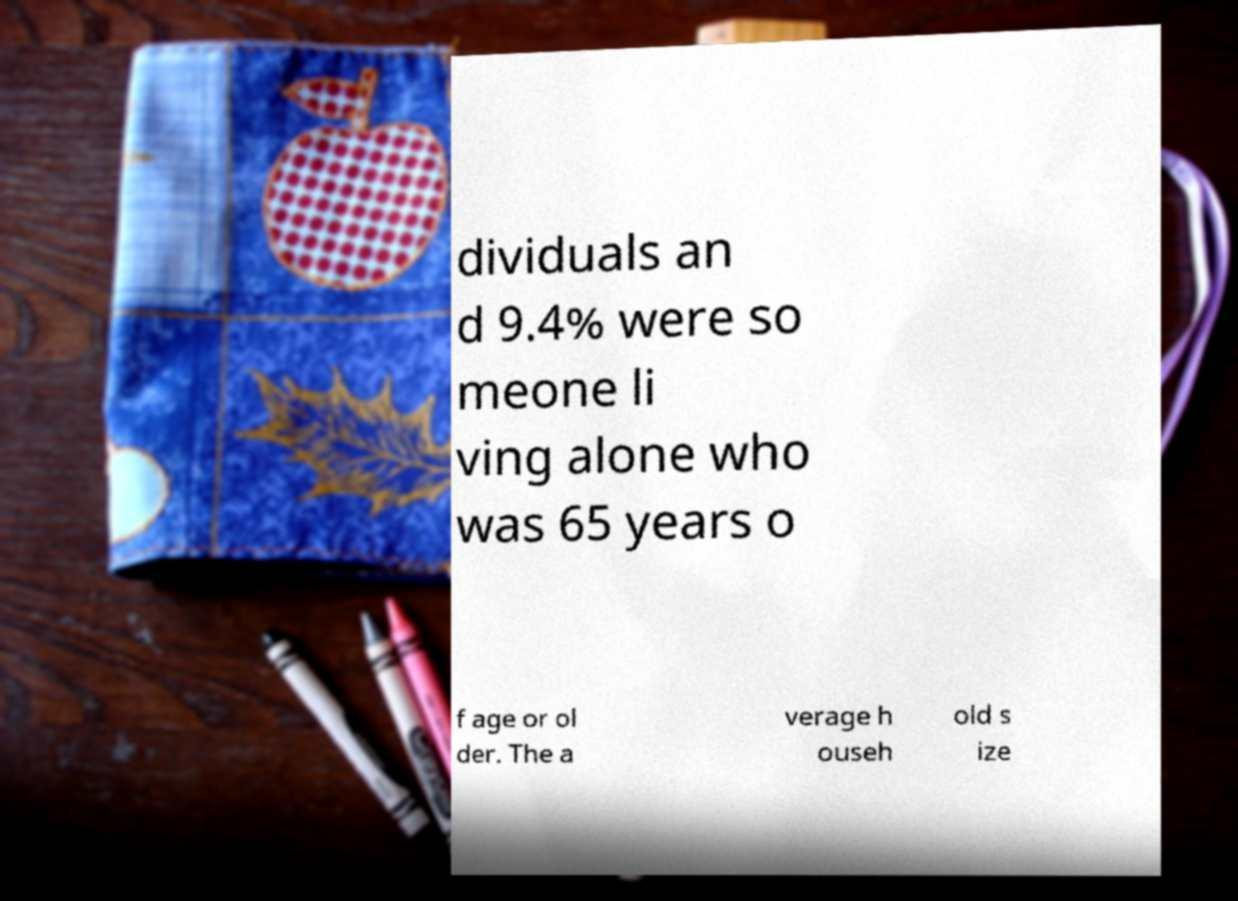I need the written content from this picture converted into text. Can you do that? dividuals an d 9.4% were so meone li ving alone who was 65 years o f age or ol der. The a verage h ouseh old s ize 